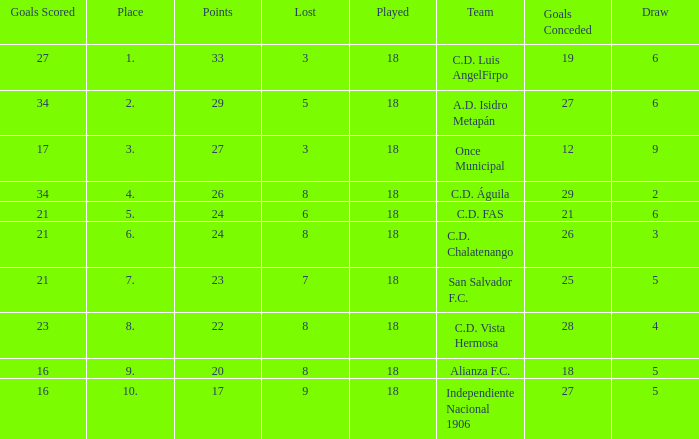What is the lowest amount of goals scored that has more than 19 goal conceded and played less than 18? None. 